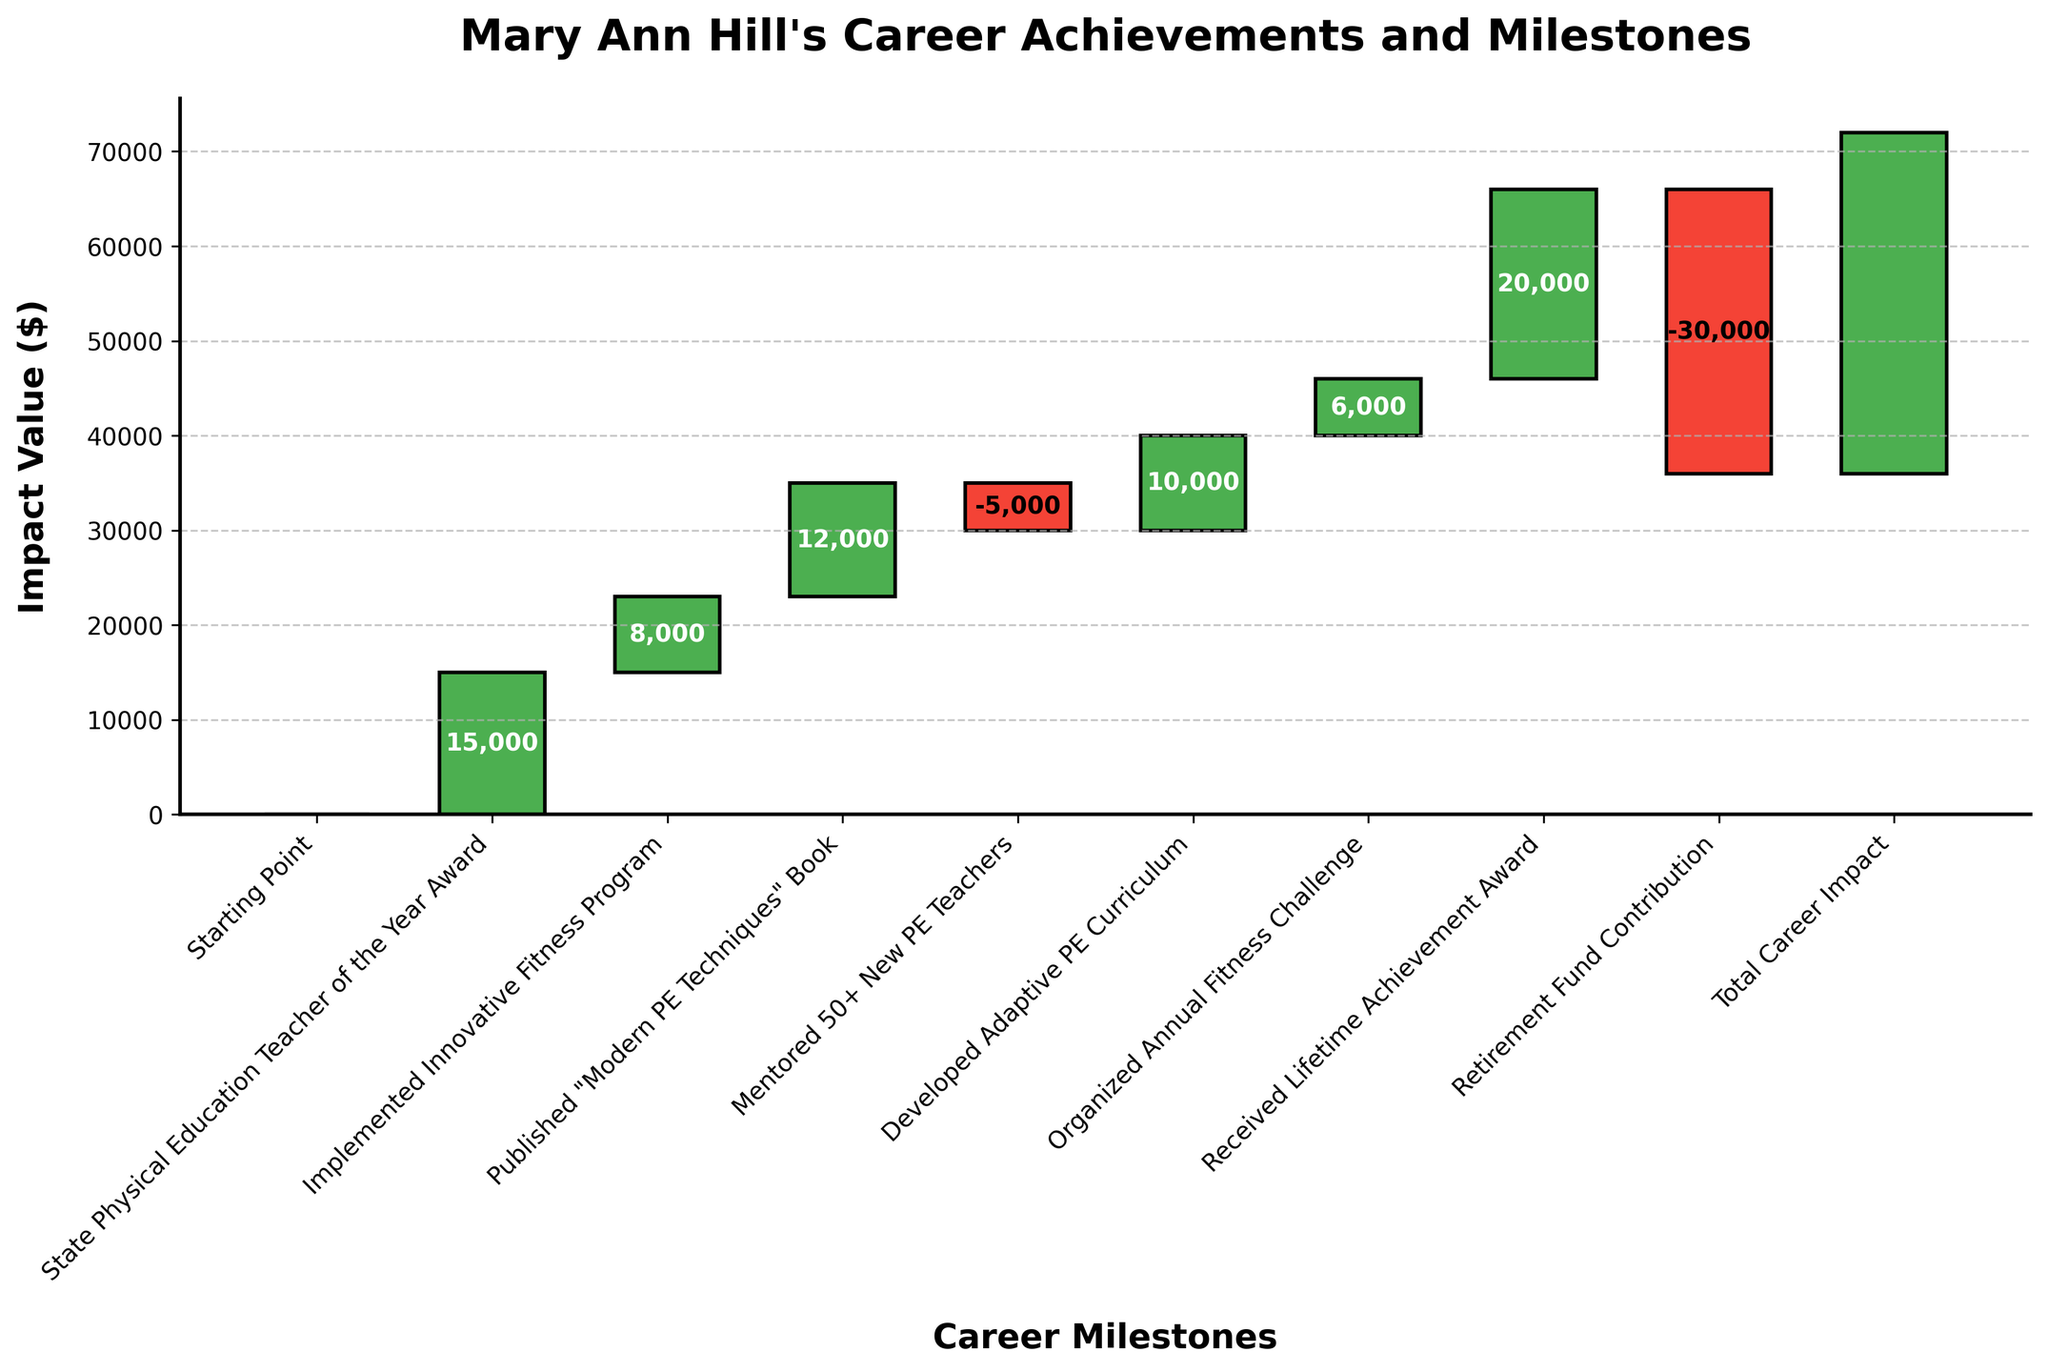What's the title of the figure? The title of the chart is located at the top in bold text. It summarizes the chart's purpose or content.
Answer: Mary Ann Hill's Career Achievements and Milestones What is the total career impact value? The total career impact value is represented by the last bar in the chart, usually labeled 'Total Career Impact'.
Answer: 36,000 How many positive milestones are shown in the chart? Count the number of bars with positive values, which are usually colored green in the chart.
Answer: 6 Does the chart include any negative impacts on Mary Ann Hill's career? Check for any bars with negative values, typically colored red, which indicate a negative impact.
Answer: Yes Which milestone had the highest positive impact? Identify the bar with the highest positive value by comparing the heights of all green bars.
Answer: Received Lifetime Achievement Award How does the impact of "Published 'Modern PE Techniques' Book" compare to "Developed Adaptive PE Curriculum"? Compare the values of these two milestones. Use the chart to see which bar is taller or has a higher positive value.
Answer: The book publication impact is higher What is the impact difference between "Mentored 50+ New PE Teachers" and "State Physical Education Teacher of the Year Award"? Subtract the value of "Mentored 50+ New PE Teachers" from "State Physical Education Teacher of the Year Award".
Answer: 20,000 What do the colors in the chart represent? The colors represent positive and negative impacts. Green bars indicate positive impacts, while red bars indicate negative impacts.
Answer: Positive and negative impacts What happens to the cumulative impact after the "Retirement Fund Contribution"? This looks at how the cumulative impact adjusts down due to the negative value of this milestone. Find the cumulative value before and after this bar.
Answer: Decreases by 30,000 